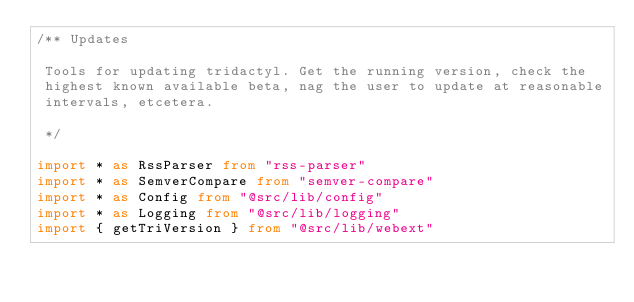<code> <loc_0><loc_0><loc_500><loc_500><_TypeScript_>/** Updates

 Tools for updating tridactyl. Get the running version, check the
 highest known available beta, nag the user to update at reasonable
 intervals, etcetera.

 */

import * as RssParser from "rss-parser"
import * as SemverCompare from "semver-compare"
import * as Config from "@src/lib/config"
import * as Logging from "@src/lib/logging"
import { getTriVersion } from "@src/lib/webext"
</code> 